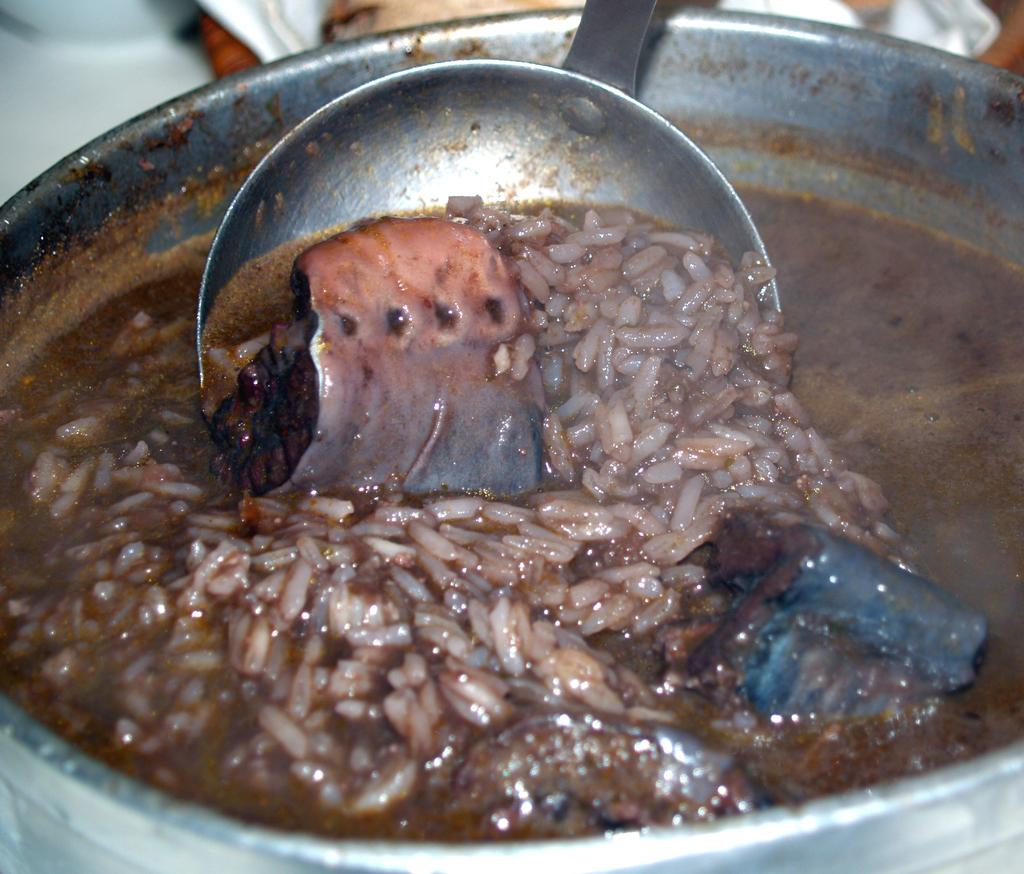What is in the bowl that is visible in the foreground of the image? There is a bowl with a food item in the foreground of the image. What utensil is present in the bowl? There is a spoon in the bowl. Can you describe any other objects visible in the image? Unfortunately, the provided facts do not specify any other objects visible in the image. What type of ink is being used to write on the train in the image? There is no train or ink present in the image. 